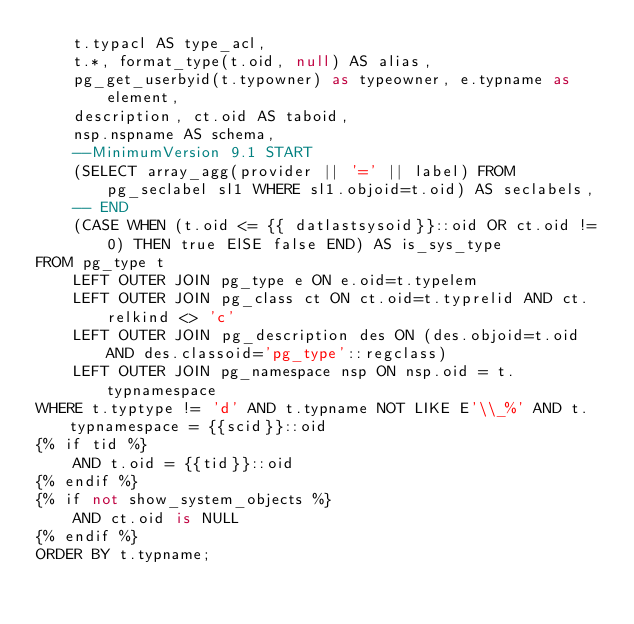Convert code to text. <code><loc_0><loc_0><loc_500><loc_500><_SQL_>    t.typacl AS type_acl,
    t.*, format_type(t.oid, null) AS alias,
    pg_get_userbyid(t.typowner) as typeowner, e.typname as element,
    description, ct.oid AS taboid,
    nsp.nspname AS schema,
    --MinimumVersion 9.1 START
    (SELECT array_agg(provider || '=' || label) FROM pg_seclabel sl1 WHERE sl1.objoid=t.oid) AS seclabels,
    -- END
    (CASE WHEN (t.oid <= {{ datlastsysoid}}::oid OR ct.oid != 0) THEN true ElSE false END) AS is_sys_type
FROM pg_type t
    LEFT OUTER JOIN pg_type e ON e.oid=t.typelem
    LEFT OUTER JOIN pg_class ct ON ct.oid=t.typrelid AND ct.relkind <> 'c'
    LEFT OUTER JOIN pg_description des ON (des.objoid=t.oid AND des.classoid='pg_type'::regclass)
    LEFT OUTER JOIN pg_namespace nsp ON nsp.oid = t.typnamespace
WHERE t.typtype != 'd' AND t.typname NOT LIKE E'\\_%' AND t.typnamespace = {{scid}}::oid
{% if tid %}
    AND t.oid = {{tid}}::oid
{% endif %}
{% if not show_system_objects %}
    AND ct.oid is NULL
{% endif %}
ORDER BY t.typname;</code> 